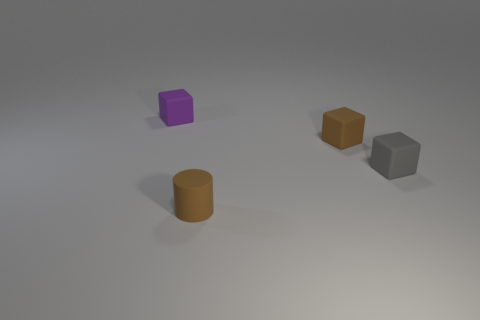How many yellow objects are there?
Offer a very short reply. 0. There is a brown object behind the gray rubber block; is its size the same as the thing that is in front of the tiny gray block?
Provide a short and direct response. Yes. Do the purple thing and the gray object have the same shape?
Ensure brevity in your answer.  Yes. What size is the brown thing that is the same shape as the gray thing?
Your answer should be compact. Small. How many purple things are the same material as the tiny brown cylinder?
Give a very brief answer. 1. How many objects are either small cylinders or small red metal spheres?
Provide a succinct answer. 1. There is a tiny matte block that is behind the small brown rubber cube; is there a tiny brown block behind it?
Provide a short and direct response. No. Are there more small brown rubber cylinders to the left of the tiny purple block than cylinders right of the small brown rubber cube?
Give a very brief answer. No. There is a tiny thing that is the same color as the matte cylinder; what is it made of?
Provide a succinct answer. Rubber. How many small cubes are the same color as the cylinder?
Keep it short and to the point. 1. 